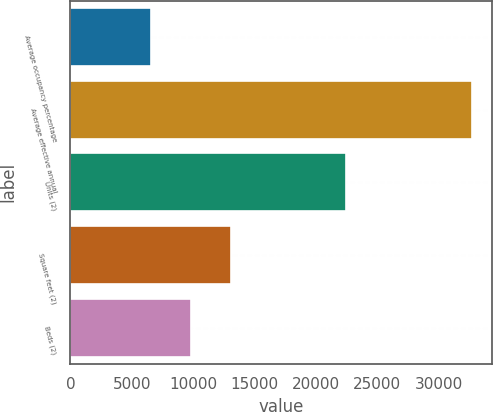<chart> <loc_0><loc_0><loc_500><loc_500><bar_chart><fcel>Average occupancy percentage<fcel>Average effective annual<fcel>Units (2)<fcel>Square feet (2)<fcel>Beds (2)<nl><fcel>6577<fcel>32741<fcel>22458<fcel>13118<fcel>9847.5<nl></chart> 